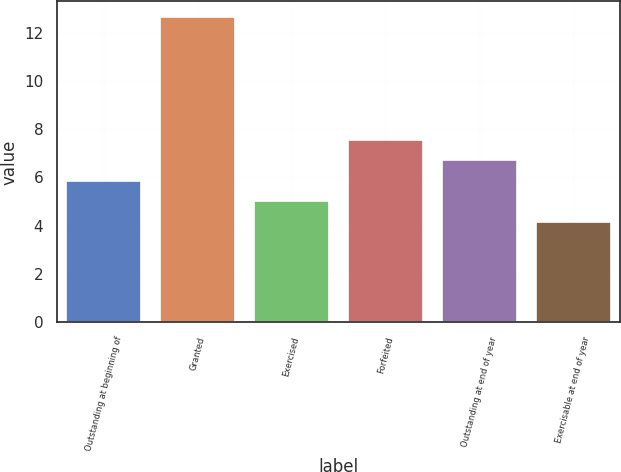<chart> <loc_0><loc_0><loc_500><loc_500><bar_chart><fcel>Outstanding at beginning of<fcel>Granted<fcel>Exercised<fcel>Forfeited<fcel>Outstanding at end of year<fcel>Exercisable at end of year<nl><fcel>5.87<fcel>12.66<fcel>5.02<fcel>7.57<fcel>6.72<fcel>4.17<nl></chart> 